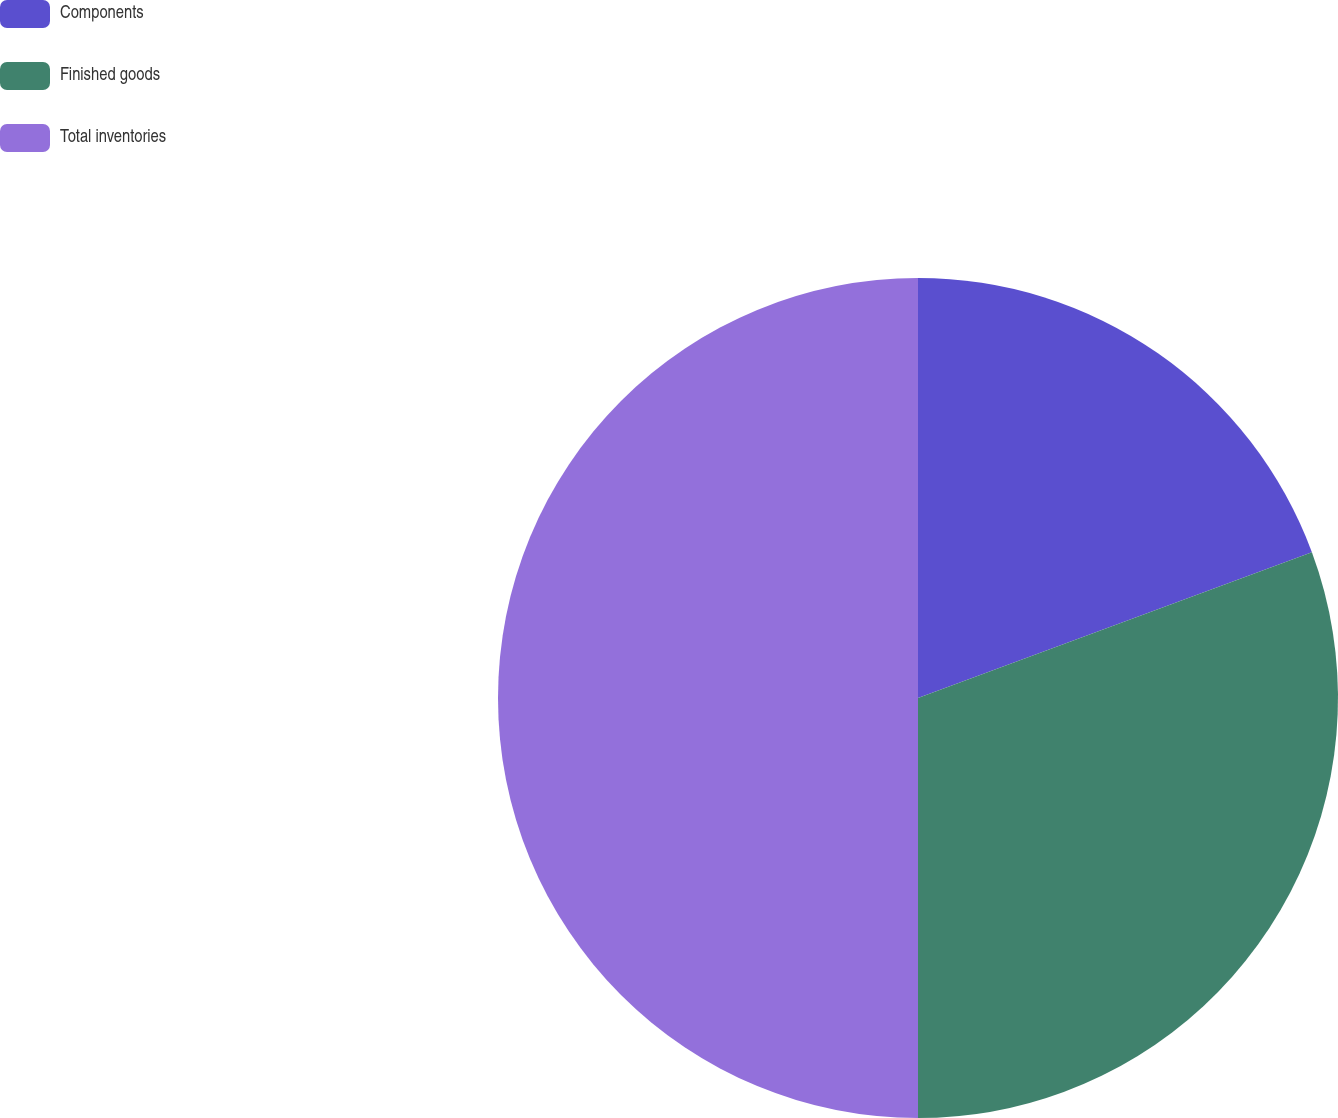<chart> <loc_0><loc_0><loc_500><loc_500><pie_chart><fcel>Components<fcel>Finished goods<fcel>Total inventories<nl><fcel>19.36%<fcel>30.64%<fcel>50.0%<nl></chart> 